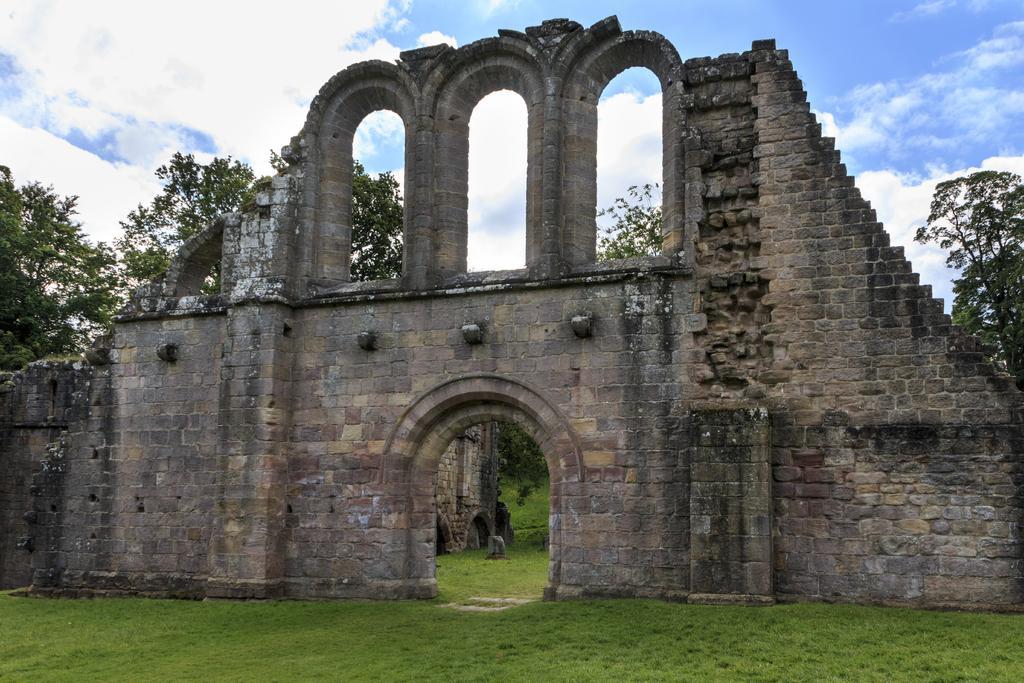In one or two sentences, can you explain what this image depicts? In this image we can see a monument. We can also see some grass, a group of trees and the sky which looks cloudy. 